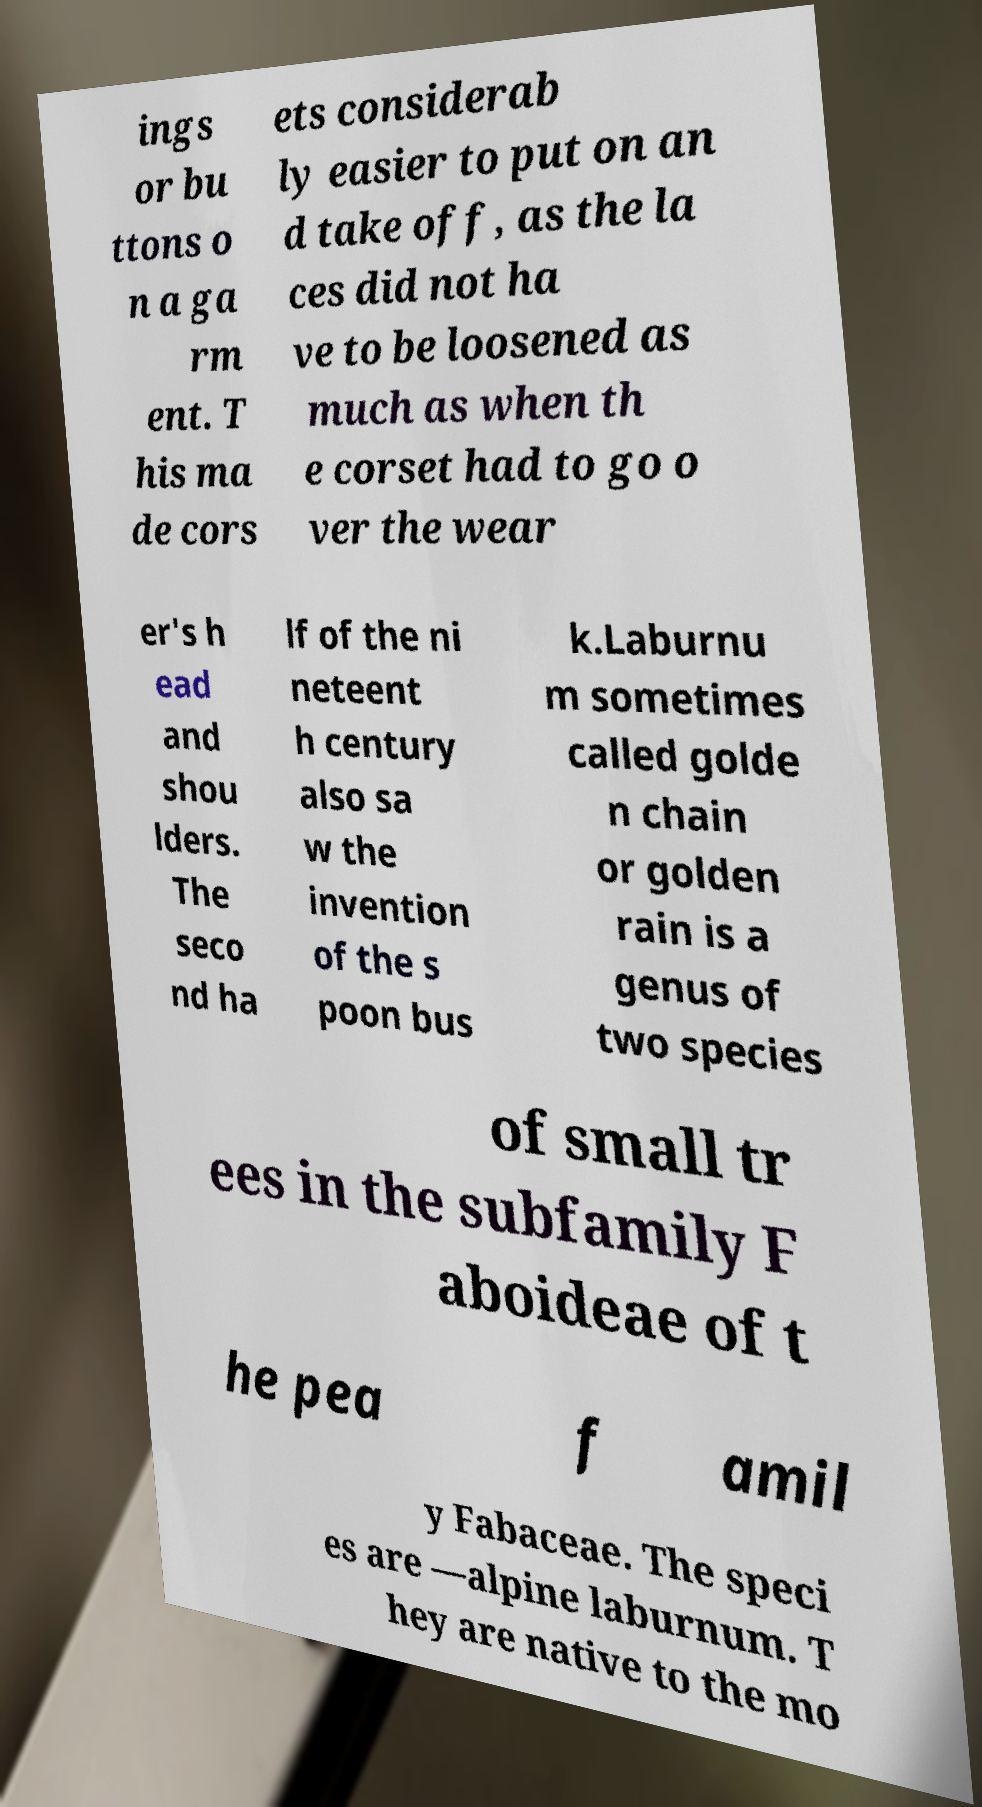Please identify and transcribe the text found in this image. ings or bu ttons o n a ga rm ent. T his ma de cors ets considerab ly easier to put on an d take off, as the la ces did not ha ve to be loosened as much as when th e corset had to go o ver the wear er's h ead and shou lders. The seco nd ha lf of the ni neteent h century also sa w the invention of the s poon bus k.Laburnu m sometimes called golde n chain or golden rain is a genus of two species of small tr ees in the subfamily F aboideae of t he pea f amil y Fabaceae. The speci es are —alpine laburnum. T hey are native to the mo 